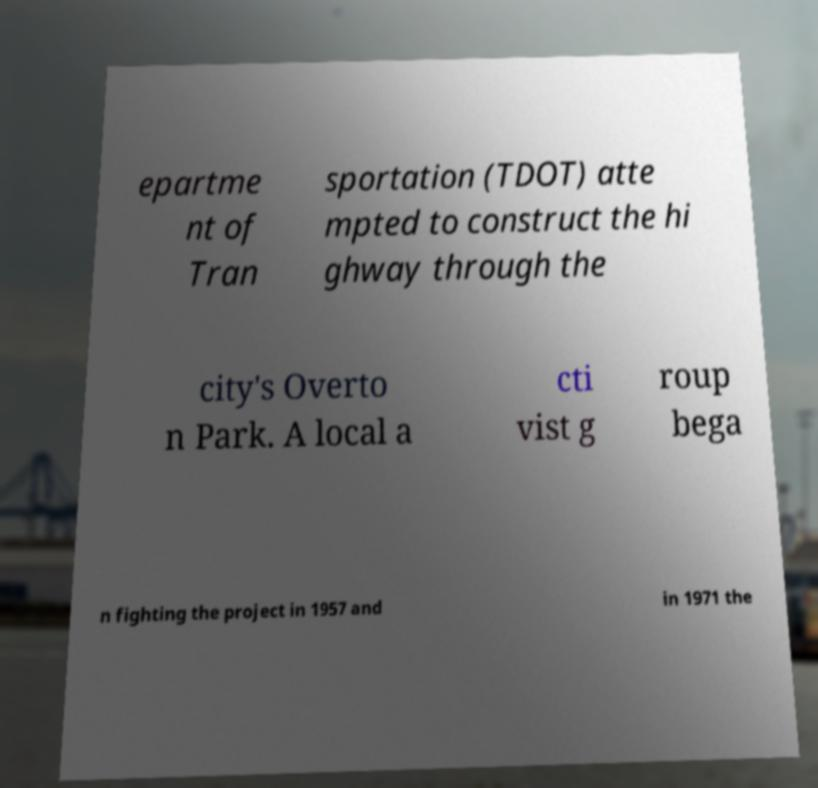What messages or text are displayed in this image? I need them in a readable, typed format. epartme nt of Tran sportation (TDOT) atte mpted to construct the hi ghway through the city's Overto n Park. A local a cti vist g roup bega n fighting the project in 1957 and in 1971 the 